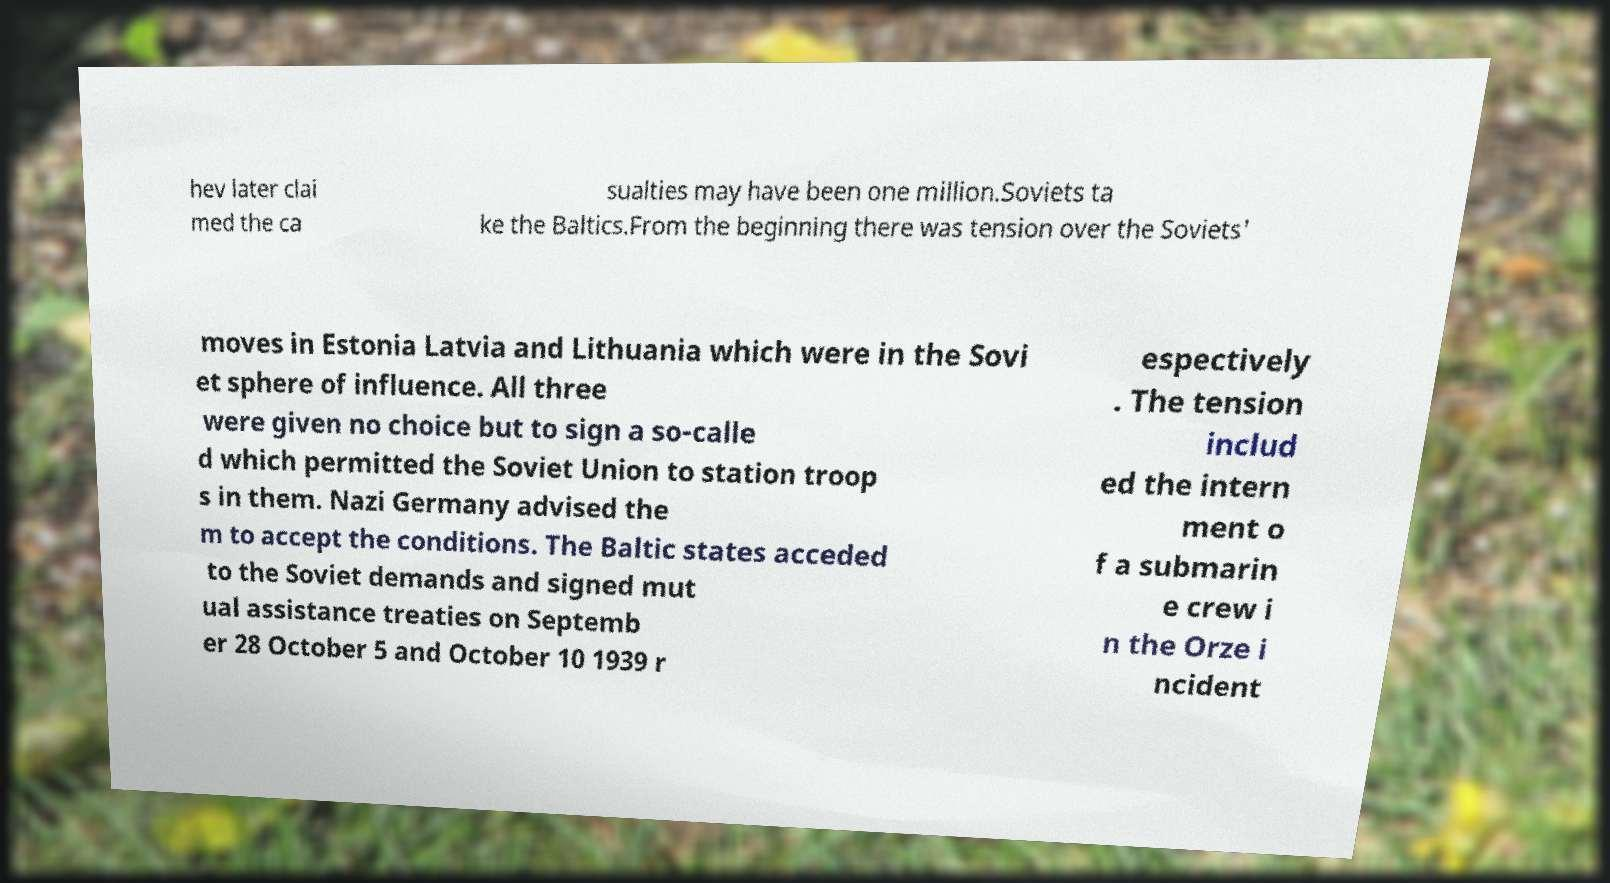For documentation purposes, I need the text within this image transcribed. Could you provide that? hev later clai med the ca sualties may have been one million.Soviets ta ke the Baltics.From the beginning there was tension over the Soviets' moves in Estonia Latvia and Lithuania which were in the Sovi et sphere of influence. All three were given no choice but to sign a so-calle d which permitted the Soviet Union to station troop s in them. Nazi Germany advised the m to accept the conditions. The Baltic states acceded to the Soviet demands and signed mut ual assistance treaties on Septemb er 28 October 5 and October 10 1939 r espectively . The tension includ ed the intern ment o f a submarin e crew i n the Orze i ncident 